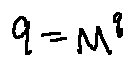<formula> <loc_0><loc_0><loc_500><loc_500>9 = M ^ { q }</formula> 